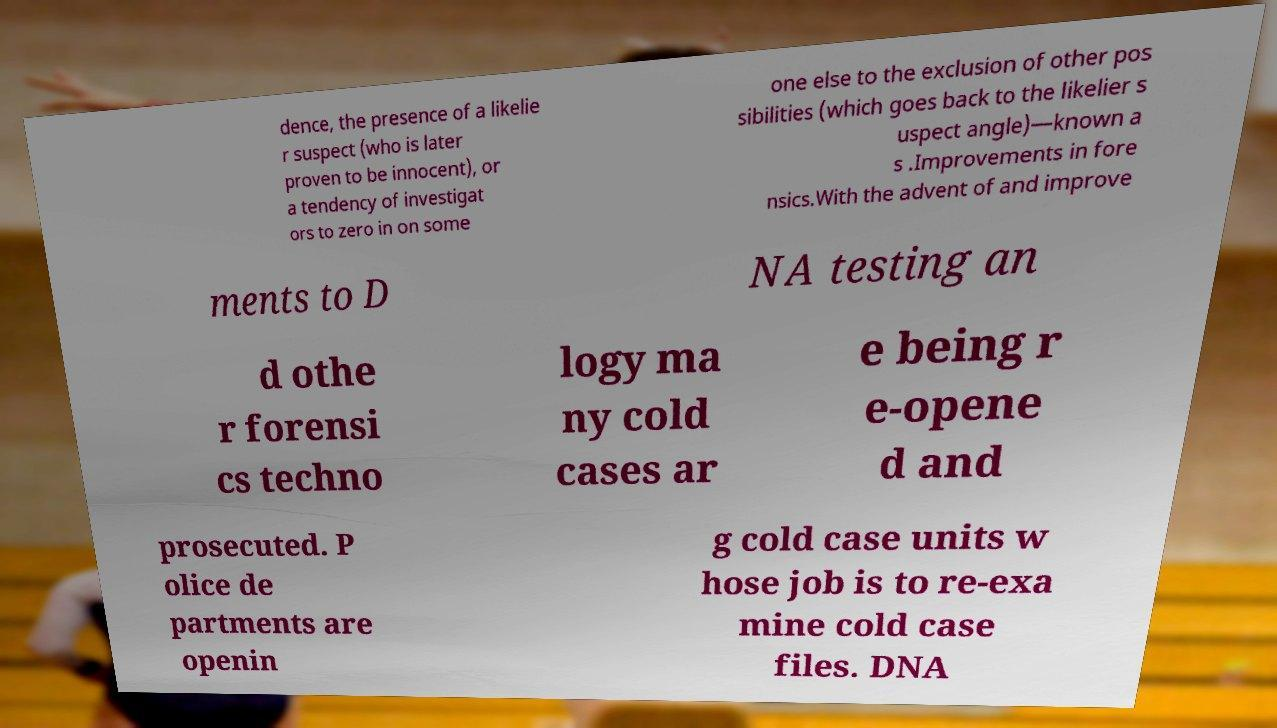Could you extract and type out the text from this image? dence, the presence of a likelie r suspect (who is later proven to be innocent), or a tendency of investigat ors to zero in on some one else to the exclusion of other pos sibilities (which goes back to the likelier s uspect angle)—known a s .Improvements in fore nsics.With the advent of and improve ments to D NA testing an d othe r forensi cs techno logy ma ny cold cases ar e being r e-opene d and prosecuted. P olice de partments are openin g cold case units w hose job is to re-exa mine cold case files. DNA 